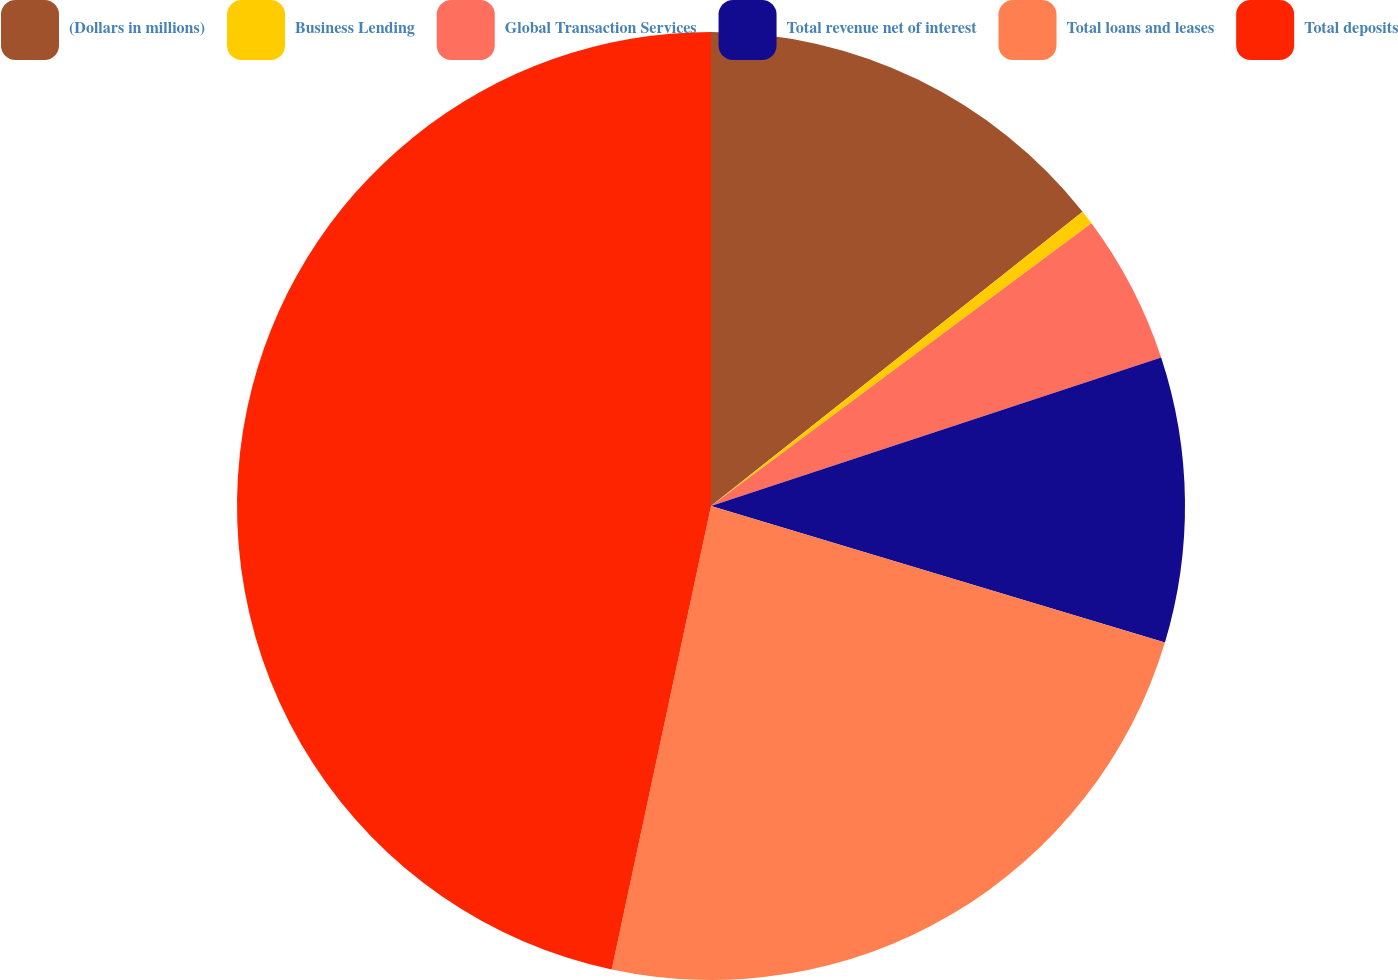Convert chart to OTSL. <chart><loc_0><loc_0><loc_500><loc_500><pie_chart><fcel>(Dollars in millions)<fcel>Business Lending<fcel>Global Transaction Services<fcel>Total revenue net of interest<fcel>Total loans and leases<fcel>Total deposits<nl><fcel>14.34%<fcel>0.49%<fcel>5.1%<fcel>9.72%<fcel>23.71%<fcel>46.64%<nl></chart> 